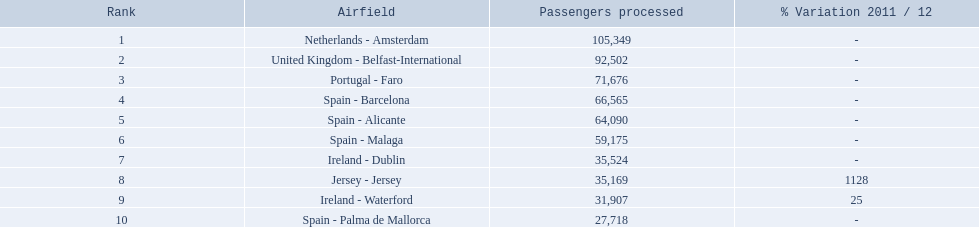What are the numbers of passengers handled along the different routes in the airport? 105,349, 92,502, 71,676, 66,565, 64,090, 59,175, 35,524, 35,169, 31,907, 27,718. Of these routes, which handles less than 30,000 passengers? Spain - Palma de Mallorca. 